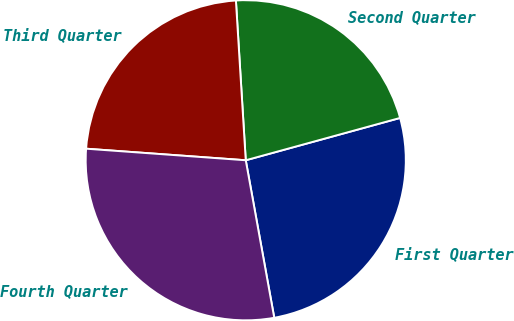<chart> <loc_0><loc_0><loc_500><loc_500><pie_chart><fcel>First Quarter<fcel>Second Quarter<fcel>Third Quarter<fcel>Fourth Quarter<nl><fcel>26.41%<fcel>21.72%<fcel>22.87%<fcel>29.0%<nl></chart> 